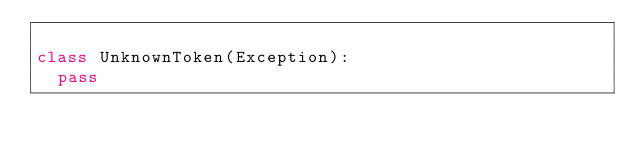<code> <loc_0><loc_0><loc_500><loc_500><_Python_>
class UnknownToken(Exception):
  pass
</code> 